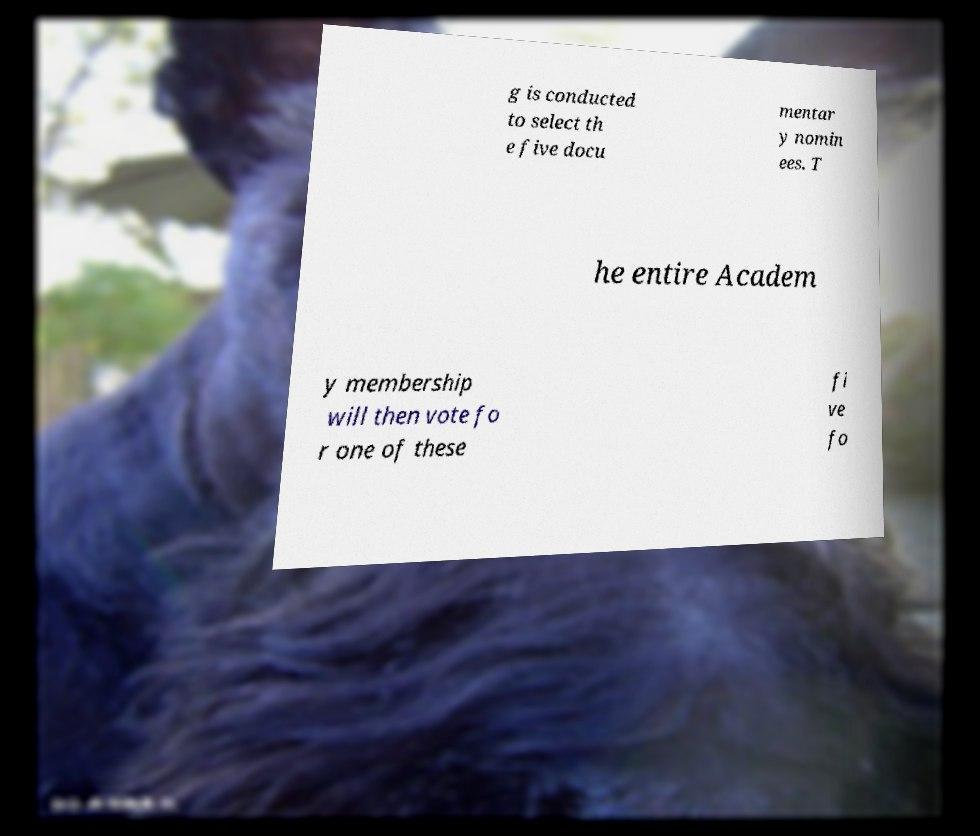I need the written content from this picture converted into text. Can you do that? g is conducted to select th e five docu mentar y nomin ees. T he entire Academ y membership will then vote fo r one of these fi ve fo 